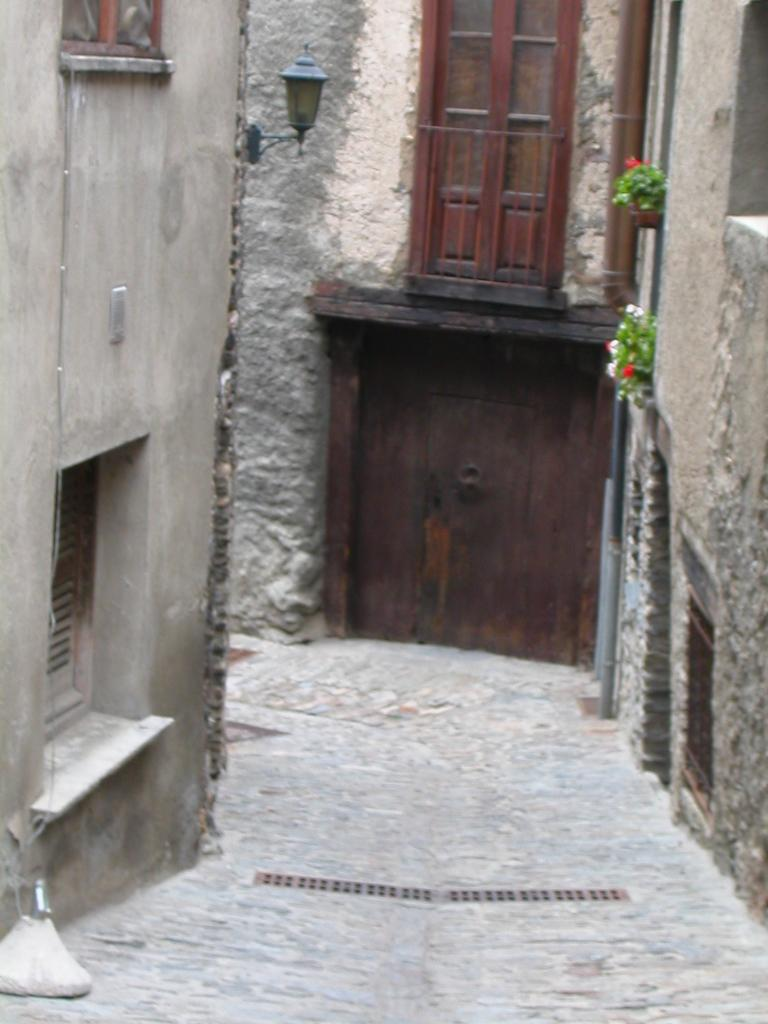What type of pathway is shown in the image? There is a lane in the image. What surrounds the lane on both sides? Buildings are present on both sides of the lane. What are the doors of the buildings made of? The buildings have wooden doors. What other features can be seen on the buildings? The buildings have windows. Can you describe the lighting in the image? There is light visible in the image. How many ants can be seen carrying yams in the image? There are no ants or yams present in the image. What type of bubble is floating near the buildings in the image? There are no bubbles present in the image. 